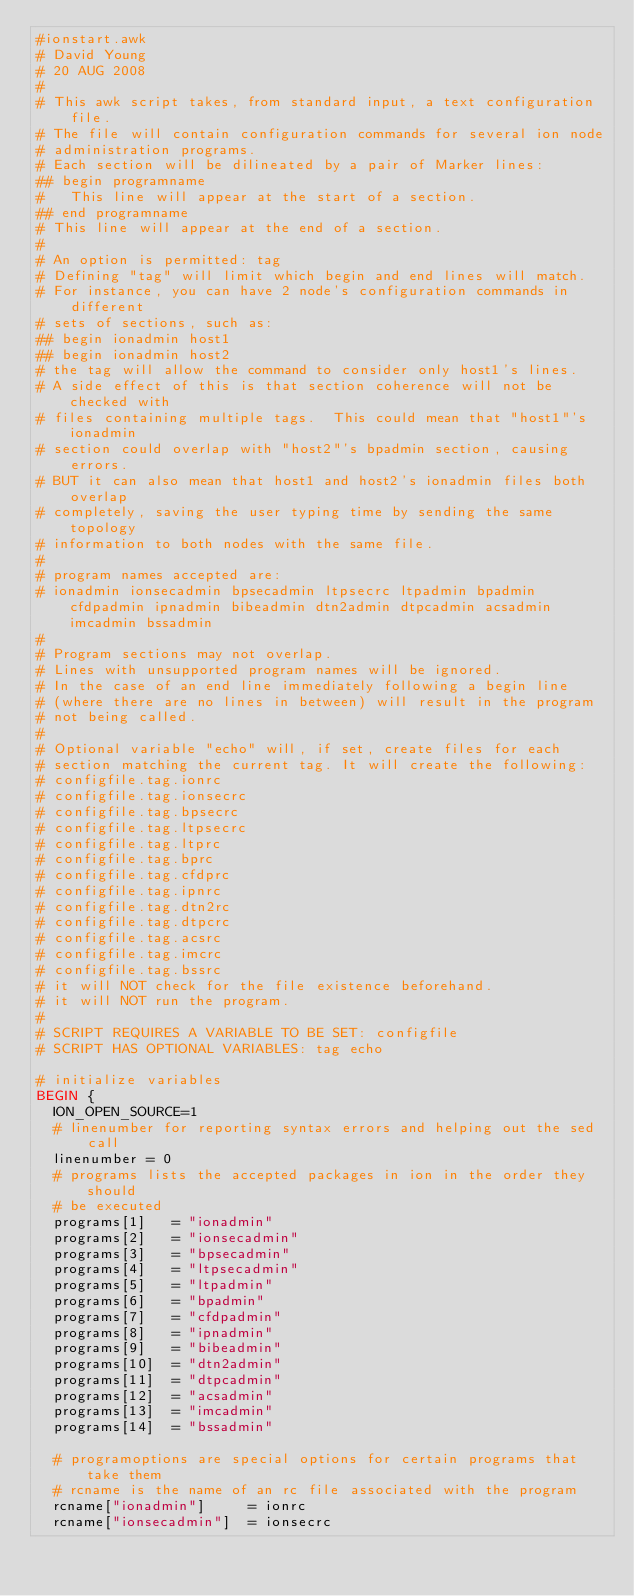<code> <loc_0><loc_0><loc_500><loc_500><_Awk_>#ionstart.awk
# David Young
# 20 AUG 2008
#
# This awk script takes, from standard input, a text configuration file.
# The file will contain configuration commands for several ion node
# administration programs.
# Each section will be dilineated by a pair of Marker lines:
## begin programname 
# 	This line will appear at the start of a section.
## end programname
#	This line will appear at the end of a section.
#
# An option is permitted: tag
# Defining "tag" will limit which begin and end lines will match.
# For instance, you can have 2 node's configuration commands in different
# sets of sections, such as:
## begin ionadmin host1
## begin ionadmin host2
# the tag will allow the command to consider only host1's lines.
# A side effect of this is that section coherence will not be checked with
# files containing multiple tags.  This could mean that "host1"'s ionadmin
# section could overlap with "host2"'s bpadmin section, causing errors.
# BUT it can also mean that host1 and host2's ionadmin files both overlap
# completely, saving the user typing time by sending the same topology
# information to both nodes with the same file.
#
# program names accepted are:
# ionadmin ionsecadmin bpsecadmin ltpsecrc ltpadmin bpadmin cfdpadmin ipnadmin bibeadmin dtn2admin dtpcadmin acsadmin imcadmin bssadmin
#
# Program sections may not overlap.
# Lines with unsupported program names will be ignored.
# In the case of an end line immediately following a begin line
# (where there are no lines in between) will result in the program
# not being called.
#
# Optional variable "echo" will, if set, create files for each
# section matching the current tag. It will create the following:
# configfile.tag.ionrc
# configfile.tag.ionsecrc
# configfile.tag.bpsecrc
# configfile.tag.ltpsecrc
# configfile.tag.ltprc
# configfile.tag.bprc
# configfile.tag.cfdprc
# configfile.tag.ipnrc
# configfile.tag.dtn2rc
# configfile.tag.dtpcrc
# configfile.tag.acsrc
# configfile.tag.imcrc
# configfile.tag.bssrc
# it will NOT check for the file existence beforehand.
# it will NOT run the program.
#
# SCRIPT REQUIRES A VARIABLE TO BE SET: configfile
# SCRIPT HAS OPTIONAL VARIABLES: tag echo

# initialize variables
BEGIN {
	ION_OPEN_SOURCE=1
	# linenumber for reporting syntax errors and helping out the sed call
	linenumber = 0
	# programs lists the accepted packages in ion in the order they should
	# be executed
	programs[1]   = "ionadmin"
	programs[2]   = "ionsecadmin"
	programs[3]   = "bpsecadmin"
	programs[4]   = "ltpsecadmin"
	programs[5]   = "ltpadmin"
	programs[6]   = "bpadmin"
	programs[7]   = "cfdpadmin"
	programs[8]   = "ipnadmin"
	programs[9]   = "bibeadmin"
	programs[10]  = "dtn2admin"
	programs[11]  = "dtpcadmin"
	programs[12]  = "acsadmin"
	programs[13]  = "imcadmin"
	programs[14]  = "bssadmin"

	# programoptions are special options for certain programs that take them
	# rcname is the name of an rc file associated with the program
	rcname["ionadmin"]     = ionrc
	rcname["ionsecadmin"]  = ionsecrc</code> 